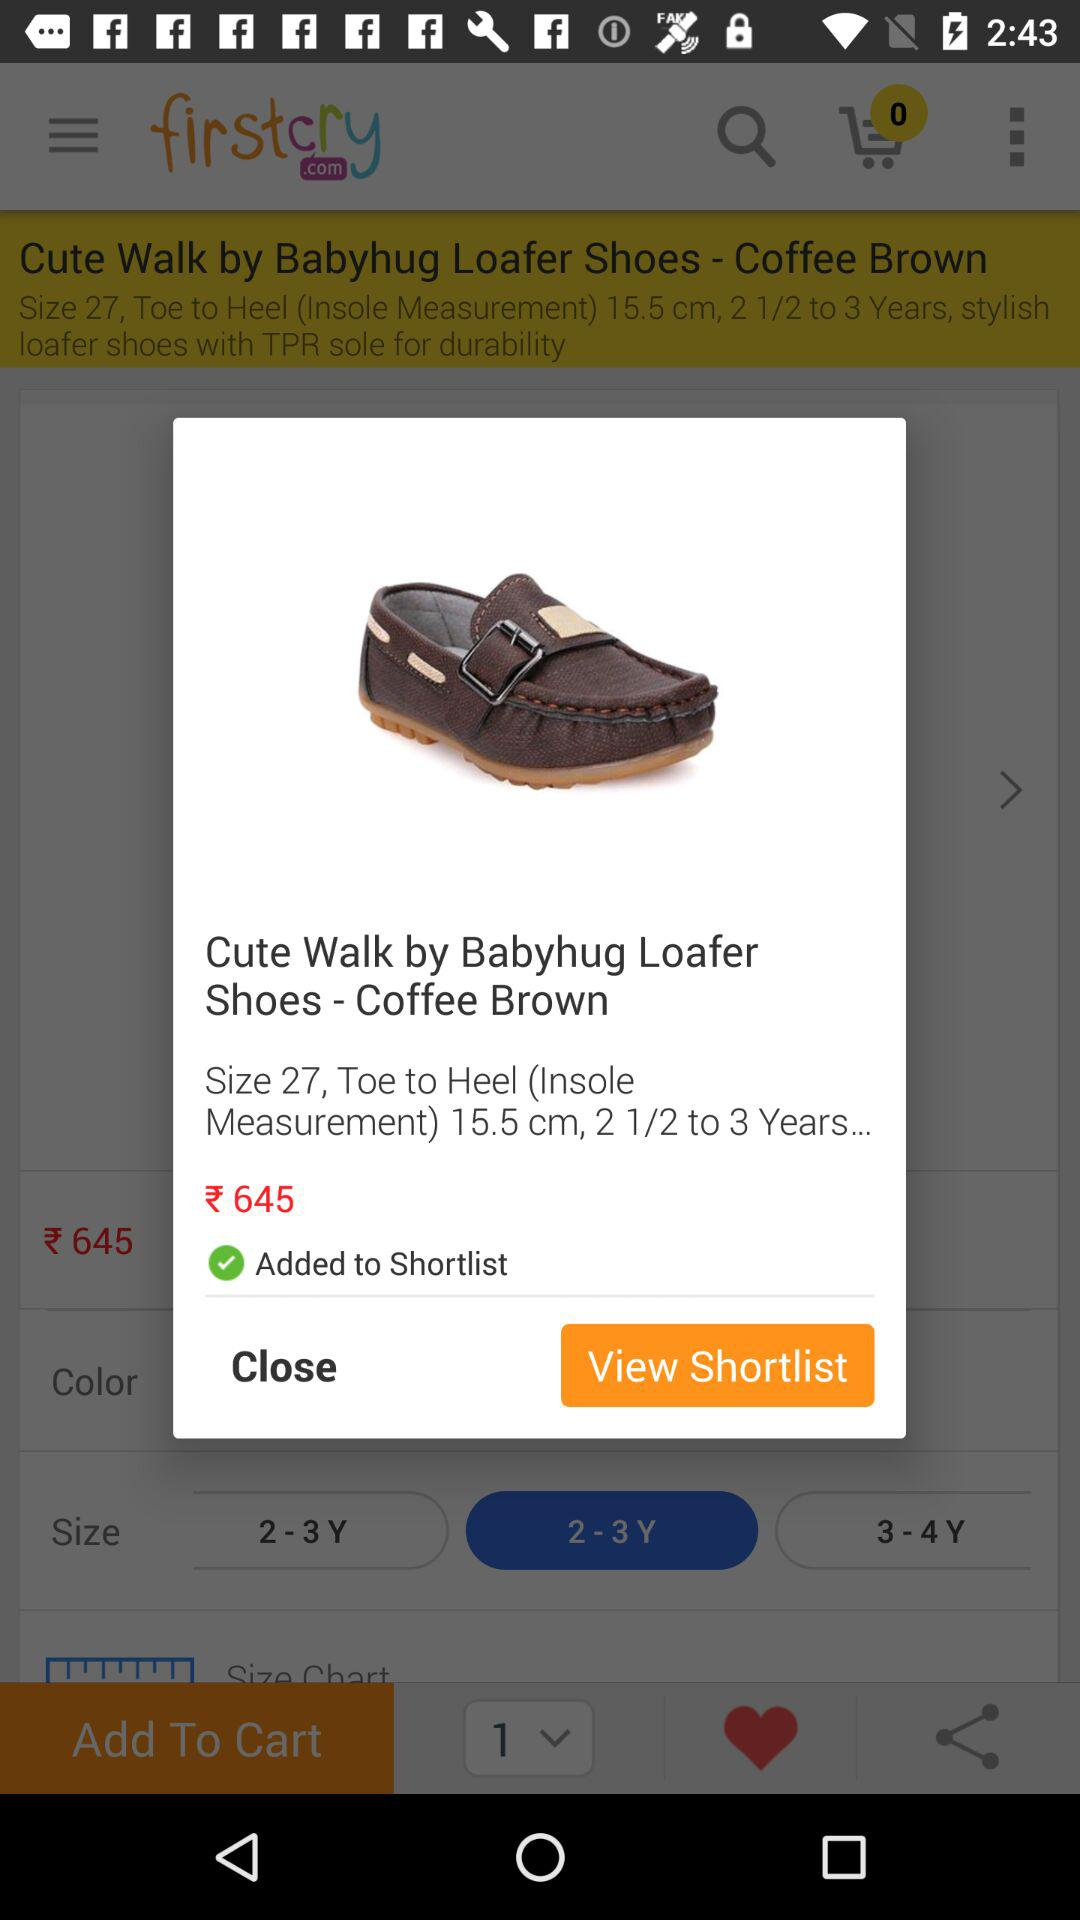Which option is selected? The selected options are "2 - 3 Y" and "1". 